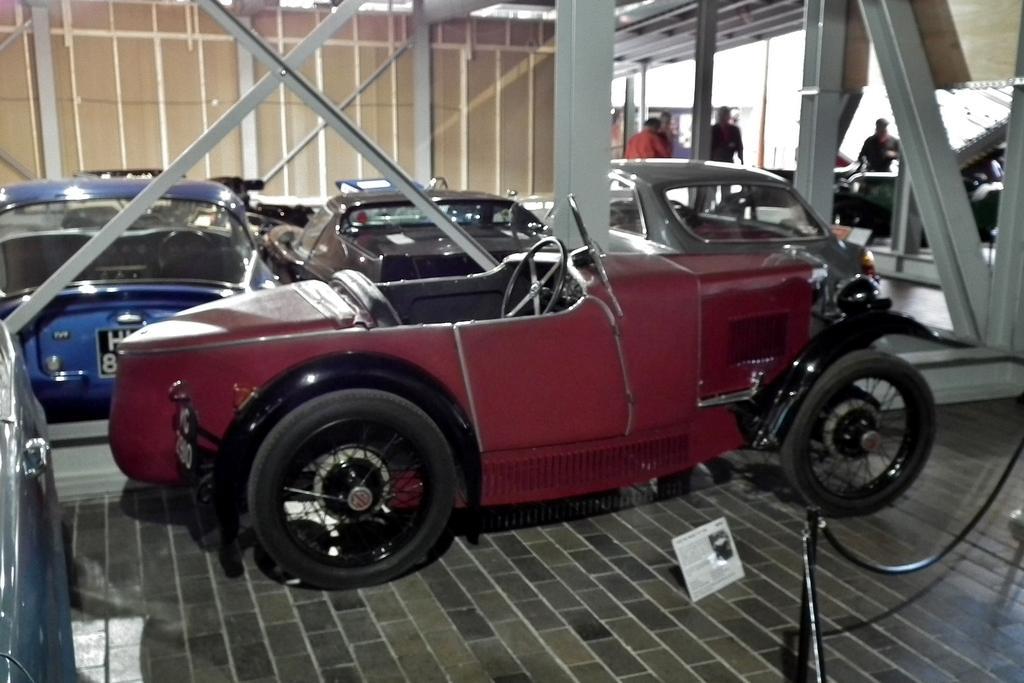Could you give a brief overview of what you see in this image? In this picture we can observe a maroon color car on the floor. There are some cars parked here. We can observe some persons standing. There are some poles. In the left side there is another car. 